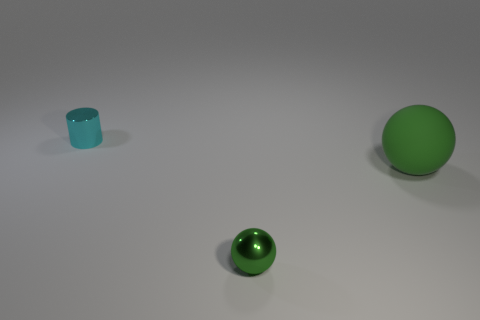Subtract all purple spheres. Subtract all purple cylinders. How many spheres are left? 2 Add 1 small purple objects. How many objects exist? 4 Subtract all cylinders. How many objects are left? 2 Add 1 small cyan objects. How many small cyan objects are left? 2 Add 3 balls. How many balls exist? 5 Subtract 0 purple cubes. How many objects are left? 3 Subtract all large matte spheres. Subtract all cylinders. How many objects are left? 1 